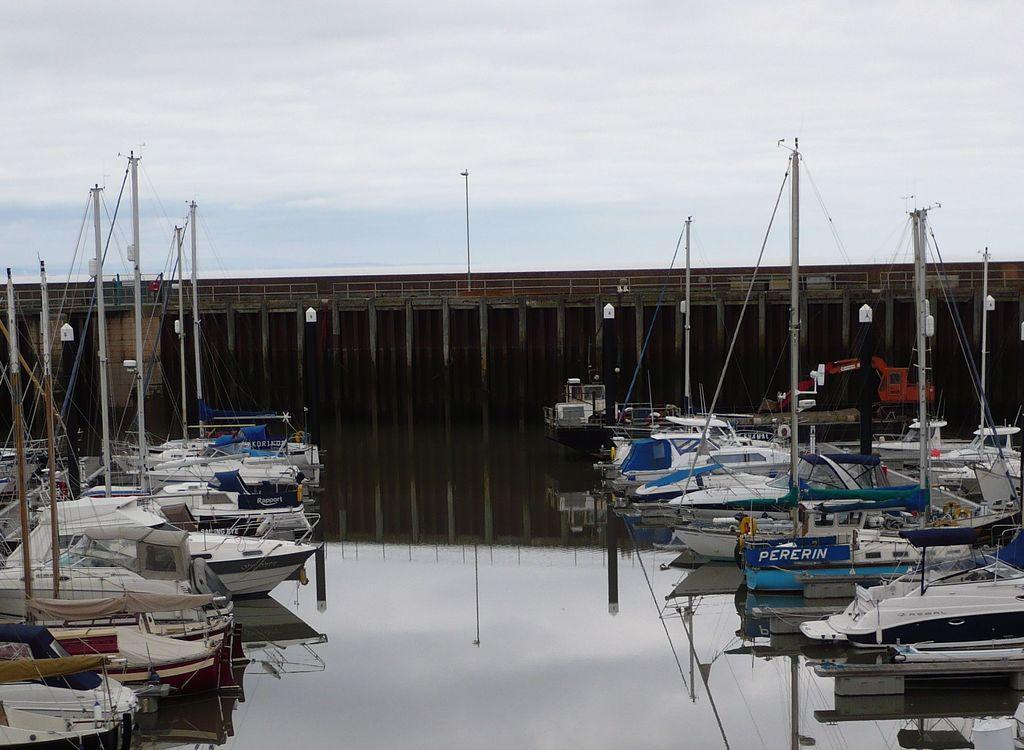In one or two sentences, can you explain what this image depicts? In this image, we can see ships and in the background, there is a bridge and we can see a pole. At the top, there is sky. 